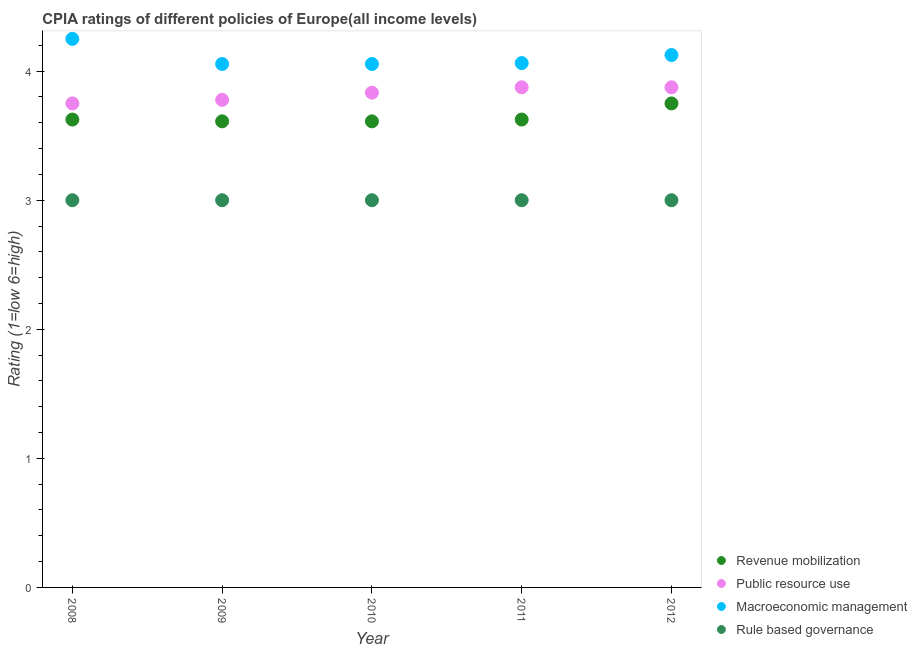How many different coloured dotlines are there?
Keep it short and to the point. 4. What is the cpia rating of public resource use in 2012?
Provide a short and direct response. 3.88. Across all years, what is the maximum cpia rating of rule based governance?
Offer a terse response. 3. What is the total cpia rating of rule based governance in the graph?
Provide a short and direct response. 15. What is the difference between the cpia rating of rule based governance in 2010 and that in 2012?
Make the answer very short. 0. What is the difference between the cpia rating of public resource use in 2011 and the cpia rating of rule based governance in 2009?
Your response must be concise. 0.88. What is the average cpia rating of revenue mobilization per year?
Give a very brief answer. 3.64. What is the ratio of the cpia rating of macroeconomic management in 2010 to that in 2012?
Your response must be concise. 0.98. Is the cpia rating of rule based governance in 2011 less than that in 2012?
Offer a very short reply. No. Is the difference between the cpia rating of revenue mobilization in 2009 and 2012 greater than the difference between the cpia rating of macroeconomic management in 2009 and 2012?
Keep it short and to the point. No. What is the difference between the highest and the lowest cpia rating of rule based governance?
Make the answer very short. 0. Is the sum of the cpia rating of rule based governance in 2009 and 2012 greater than the maximum cpia rating of revenue mobilization across all years?
Offer a very short reply. Yes. Is it the case that in every year, the sum of the cpia rating of macroeconomic management and cpia rating of public resource use is greater than the sum of cpia rating of revenue mobilization and cpia rating of rule based governance?
Ensure brevity in your answer.  No. Is it the case that in every year, the sum of the cpia rating of revenue mobilization and cpia rating of public resource use is greater than the cpia rating of macroeconomic management?
Make the answer very short. Yes. Is the cpia rating of public resource use strictly greater than the cpia rating of revenue mobilization over the years?
Your answer should be compact. Yes. Is the cpia rating of macroeconomic management strictly less than the cpia rating of public resource use over the years?
Provide a short and direct response. No. How many years are there in the graph?
Your answer should be compact. 5. Are the values on the major ticks of Y-axis written in scientific E-notation?
Offer a very short reply. No. Does the graph contain grids?
Your response must be concise. No. What is the title of the graph?
Give a very brief answer. CPIA ratings of different policies of Europe(all income levels). What is the label or title of the X-axis?
Your answer should be very brief. Year. What is the Rating (1=low 6=high) of Revenue mobilization in 2008?
Your answer should be very brief. 3.62. What is the Rating (1=low 6=high) of Public resource use in 2008?
Give a very brief answer. 3.75. What is the Rating (1=low 6=high) of Macroeconomic management in 2008?
Provide a short and direct response. 4.25. What is the Rating (1=low 6=high) in Rule based governance in 2008?
Keep it short and to the point. 3. What is the Rating (1=low 6=high) in Revenue mobilization in 2009?
Offer a terse response. 3.61. What is the Rating (1=low 6=high) in Public resource use in 2009?
Give a very brief answer. 3.78. What is the Rating (1=low 6=high) of Macroeconomic management in 2009?
Ensure brevity in your answer.  4.06. What is the Rating (1=low 6=high) of Revenue mobilization in 2010?
Provide a short and direct response. 3.61. What is the Rating (1=low 6=high) in Public resource use in 2010?
Your answer should be very brief. 3.83. What is the Rating (1=low 6=high) of Macroeconomic management in 2010?
Give a very brief answer. 4.06. What is the Rating (1=low 6=high) in Revenue mobilization in 2011?
Provide a succinct answer. 3.62. What is the Rating (1=low 6=high) of Public resource use in 2011?
Your answer should be very brief. 3.88. What is the Rating (1=low 6=high) of Macroeconomic management in 2011?
Provide a succinct answer. 4.06. What is the Rating (1=low 6=high) of Revenue mobilization in 2012?
Your answer should be compact. 3.75. What is the Rating (1=low 6=high) in Public resource use in 2012?
Keep it short and to the point. 3.88. What is the Rating (1=low 6=high) in Macroeconomic management in 2012?
Provide a succinct answer. 4.12. What is the Rating (1=low 6=high) of Rule based governance in 2012?
Provide a succinct answer. 3. Across all years, what is the maximum Rating (1=low 6=high) of Revenue mobilization?
Give a very brief answer. 3.75. Across all years, what is the maximum Rating (1=low 6=high) in Public resource use?
Your response must be concise. 3.88. Across all years, what is the maximum Rating (1=low 6=high) in Macroeconomic management?
Offer a very short reply. 4.25. Across all years, what is the maximum Rating (1=low 6=high) in Rule based governance?
Your answer should be very brief. 3. Across all years, what is the minimum Rating (1=low 6=high) of Revenue mobilization?
Provide a succinct answer. 3.61. Across all years, what is the minimum Rating (1=low 6=high) in Public resource use?
Your response must be concise. 3.75. Across all years, what is the minimum Rating (1=low 6=high) of Macroeconomic management?
Your answer should be compact. 4.06. Across all years, what is the minimum Rating (1=low 6=high) in Rule based governance?
Offer a terse response. 3. What is the total Rating (1=low 6=high) of Revenue mobilization in the graph?
Your response must be concise. 18.22. What is the total Rating (1=low 6=high) in Public resource use in the graph?
Your response must be concise. 19.11. What is the total Rating (1=low 6=high) of Macroeconomic management in the graph?
Provide a succinct answer. 20.55. What is the total Rating (1=low 6=high) in Rule based governance in the graph?
Make the answer very short. 15. What is the difference between the Rating (1=low 6=high) of Revenue mobilization in 2008 and that in 2009?
Ensure brevity in your answer.  0.01. What is the difference between the Rating (1=low 6=high) of Public resource use in 2008 and that in 2009?
Make the answer very short. -0.03. What is the difference between the Rating (1=low 6=high) of Macroeconomic management in 2008 and that in 2009?
Your answer should be very brief. 0.19. What is the difference between the Rating (1=low 6=high) in Revenue mobilization in 2008 and that in 2010?
Provide a succinct answer. 0.01. What is the difference between the Rating (1=low 6=high) of Public resource use in 2008 and that in 2010?
Keep it short and to the point. -0.08. What is the difference between the Rating (1=low 6=high) of Macroeconomic management in 2008 and that in 2010?
Make the answer very short. 0.19. What is the difference between the Rating (1=low 6=high) in Public resource use in 2008 and that in 2011?
Offer a terse response. -0.12. What is the difference between the Rating (1=low 6=high) in Macroeconomic management in 2008 and that in 2011?
Provide a succinct answer. 0.19. What is the difference between the Rating (1=low 6=high) of Rule based governance in 2008 and that in 2011?
Offer a terse response. 0. What is the difference between the Rating (1=low 6=high) in Revenue mobilization in 2008 and that in 2012?
Provide a short and direct response. -0.12. What is the difference between the Rating (1=low 6=high) in Public resource use in 2008 and that in 2012?
Offer a very short reply. -0.12. What is the difference between the Rating (1=low 6=high) in Macroeconomic management in 2008 and that in 2012?
Give a very brief answer. 0.12. What is the difference between the Rating (1=low 6=high) of Rule based governance in 2008 and that in 2012?
Provide a succinct answer. 0. What is the difference between the Rating (1=low 6=high) in Revenue mobilization in 2009 and that in 2010?
Ensure brevity in your answer.  0. What is the difference between the Rating (1=low 6=high) of Public resource use in 2009 and that in 2010?
Keep it short and to the point. -0.06. What is the difference between the Rating (1=low 6=high) of Macroeconomic management in 2009 and that in 2010?
Provide a succinct answer. 0. What is the difference between the Rating (1=low 6=high) of Rule based governance in 2009 and that in 2010?
Provide a succinct answer. 0. What is the difference between the Rating (1=low 6=high) in Revenue mobilization in 2009 and that in 2011?
Your answer should be very brief. -0.01. What is the difference between the Rating (1=low 6=high) in Public resource use in 2009 and that in 2011?
Make the answer very short. -0.1. What is the difference between the Rating (1=low 6=high) in Macroeconomic management in 2009 and that in 2011?
Offer a very short reply. -0.01. What is the difference between the Rating (1=low 6=high) in Rule based governance in 2009 and that in 2011?
Ensure brevity in your answer.  0. What is the difference between the Rating (1=low 6=high) in Revenue mobilization in 2009 and that in 2012?
Keep it short and to the point. -0.14. What is the difference between the Rating (1=low 6=high) in Public resource use in 2009 and that in 2012?
Ensure brevity in your answer.  -0.1. What is the difference between the Rating (1=low 6=high) of Macroeconomic management in 2009 and that in 2012?
Ensure brevity in your answer.  -0.07. What is the difference between the Rating (1=low 6=high) in Revenue mobilization in 2010 and that in 2011?
Keep it short and to the point. -0.01. What is the difference between the Rating (1=low 6=high) in Public resource use in 2010 and that in 2011?
Ensure brevity in your answer.  -0.04. What is the difference between the Rating (1=low 6=high) of Macroeconomic management in 2010 and that in 2011?
Ensure brevity in your answer.  -0.01. What is the difference between the Rating (1=low 6=high) of Rule based governance in 2010 and that in 2011?
Offer a very short reply. 0. What is the difference between the Rating (1=low 6=high) in Revenue mobilization in 2010 and that in 2012?
Provide a succinct answer. -0.14. What is the difference between the Rating (1=low 6=high) in Public resource use in 2010 and that in 2012?
Make the answer very short. -0.04. What is the difference between the Rating (1=low 6=high) in Macroeconomic management in 2010 and that in 2012?
Keep it short and to the point. -0.07. What is the difference between the Rating (1=low 6=high) of Revenue mobilization in 2011 and that in 2012?
Keep it short and to the point. -0.12. What is the difference between the Rating (1=low 6=high) of Public resource use in 2011 and that in 2012?
Provide a short and direct response. 0. What is the difference between the Rating (1=low 6=high) of Macroeconomic management in 2011 and that in 2012?
Give a very brief answer. -0.06. What is the difference between the Rating (1=low 6=high) of Revenue mobilization in 2008 and the Rating (1=low 6=high) of Public resource use in 2009?
Your answer should be compact. -0.15. What is the difference between the Rating (1=low 6=high) of Revenue mobilization in 2008 and the Rating (1=low 6=high) of Macroeconomic management in 2009?
Your answer should be compact. -0.43. What is the difference between the Rating (1=low 6=high) in Revenue mobilization in 2008 and the Rating (1=low 6=high) in Rule based governance in 2009?
Your response must be concise. 0.62. What is the difference between the Rating (1=low 6=high) of Public resource use in 2008 and the Rating (1=low 6=high) of Macroeconomic management in 2009?
Keep it short and to the point. -0.31. What is the difference between the Rating (1=low 6=high) in Public resource use in 2008 and the Rating (1=low 6=high) in Rule based governance in 2009?
Offer a terse response. 0.75. What is the difference between the Rating (1=low 6=high) of Revenue mobilization in 2008 and the Rating (1=low 6=high) of Public resource use in 2010?
Make the answer very short. -0.21. What is the difference between the Rating (1=low 6=high) in Revenue mobilization in 2008 and the Rating (1=low 6=high) in Macroeconomic management in 2010?
Make the answer very short. -0.43. What is the difference between the Rating (1=low 6=high) in Public resource use in 2008 and the Rating (1=low 6=high) in Macroeconomic management in 2010?
Make the answer very short. -0.31. What is the difference between the Rating (1=low 6=high) of Public resource use in 2008 and the Rating (1=low 6=high) of Rule based governance in 2010?
Ensure brevity in your answer.  0.75. What is the difference between the Rating (1=low 6=high) in Revenue mobilization in 2008 and the Rating (1=low 6=high) in Macroeconomic management in 2011?
Offer a very short reply. -0.44. What is the difference between the Rating (1=low 6=high) in Public resource use in 2008 and the Rating (1=low 6=high) in Macroeconomic management in 2011?
Provide a succinct answer. -0.31. What is the difference between the Rating (1=low 6=high) in Macroeconomic management in 2008 and the Rating (1=low 6=high) in Rule based governance in 2011?
Provide a short and direct response. 1.25. What is the difference between the Rating (1=low 6=high) of Revenue mobilization in 2008 and the Rating (1=low 6=high) of Public resource use in 2012?
Your answer should be very brief. -0.25. What is the difference between the Rating (1=low 6=high) of Revenue mobilization in 2008 and the Rating (1=low 6=high) of Rule based governance in 2012?
Offer a terse response. 0.62. What is the difference between the Rating (1=low 6=high) in Public resource use in 2008 and the Rating (1=low 6=high) in Macroeconomic management in 2012?
Ensure brevity in your answer.  -0.38. What is the difference between the Rating (1=low 6=high) in Macroeconomic management in 2008 and the Rating (1=low 6=high) in Rule based governance in 2012?
Provide a succinct answer. 1.25. What is the difference between the Rating (1=low 6=high) in Revenue mobilization in 2009 and the Rating (1=low 6=high) in Public resource use in 2010?
Provide a succinct answer. -0.22. What is the difference between the Rating (1=low 6=high) in Revenue mobilization in 2009 and the Rating (1=low 6=high) in Macroeconomic management in 2010?
Your answer should be compact. -0.44. What is the difference between the Rating (1=low 6=high) of Revenue mobilization in 2009 and the Rating (1=low 6=high) of Rule based governance in 2010?
Make the answer very short. 0.61. What is the difference between the Rating (1=low 6=high) of Public resource use in 2009 and the Rating (1=low 6=high) of Macroeconomic management in 2010?
Offer a terse response. -0.28. What is the difference between the Rating (1=low 6=high) in Public resource use in 2009 and the Rating (1=low 6=high) in Rule based governance in 2010?
Give a very brief answer. 0.78. What is the difference between the Rating (1=low 6=high) in Macroeconomic management in 2009 and the Rating (1=low 6=high) in Rule based governance in 2010?
Offer a terse response. 1.06. What is the difference between the Rating (1=low 6=high) in Revenue mobilization in 2009 and the Rating (1=low 6=high) in Public resource use in 2011?
Provide a short and direct response. -0.26. What is the difference between the Rating (1=low 6=high) of Revenue mobilization in 2009 and the Rating (1=low 6=high) of Macroeconomic management in 2011?
Your answer should be very brief. -0.45. What is the difference between the Rating (1=low 6=high) in Revenue mobilization in 2009 and the Rating (1=low 6=high) in Rule based governance in 2011?
Ensure brevity in your answer.  0.61. What is the difference between the Rating (1=low 6=high) of Public resource use in 2009 and the Rating (1=low 6=high) of Macroeconomic management in 2011?
Give a very brief answer. -0.28. What is the difference between the Rating (1=low 6=high) in Public resource use in 2009 and the Rating (1=low 6=high) in Rule based governance in 2011?
Provide a succinct answer. 0.78. What is the difference between the Rating (1=low 6=high) in Macroeconomic management in 2009 and the Rating (1=low 6=high) in Rule based governance in 2011?
Your response must be concise. 1.06. What is the difference between the Rating (1=low 6=high) of Revenue mobilization in 2009 and the Rating (1=low 6=high) of Public resource use in 2012?
Make the answer very short. -0.26. What is the difference between the Rating (1=low 6=high) of Revenue mobilization in 2009 and the Rating (1=low 6=high) of Macroeconomic management in 2012?
Provide a succinct answer. -0.51. What is the difference between the Rating (1=low 6=high) of Revenue mobilization in 2009 and the Rating (1=low 6=high) of Rule based governance in 2012?
Provide a succinct answer. 0.61. What is the difference between the Rating (1=low 6=high) in Public resource use in 2009 and the Rating (1=low 6=high) in Macroeconomic management in 2012?
Keep it short and to the point. -0.35. What is the difference between the Rating (1=low 6=high) of Macroeconomic management in 2009 and the Rating (1=low 6=high) of Rule based governance in 2012?
Provide a short and direct response. 1.06. What is the difference between the Rating (1=low 6=high) in Revenue mobilization in 2010 and the Rating (1=low 6=high) in Public resource use in 2011?
Make the answer very short. -0.26. What is the difference between the Rating (1=low 6=high) of Revenue mobilization in 2010 and the Rating (1=low 6=high) of Macroeconomic management in 2011?
Provide a succinct answer. -0.45. What is the difference between the Rating (1=low 6=high) in Revenue mobilization in 2010 and the Rating (1=low 6=high) in Rule based governance in 2011?
Keep it short and to the point. 0.61. What is the difference between the Rating (1=low 6=high) in Public resource use in 2010 and the Rating (1=low 6=high) in Macroeconomic management in 2011?
Provide a short and direct response. -0.23. What is the difference between the Rating (1=low 6=high) in Macroeconomic management in 2010 and the Rating (1=low 6=high) in Rule based governance in 2011?
Your answer should be compact. 1.06. What is the difference between the Rating (1=low 6=high) in Revenue mobilization in 2010 and the Rating (1=low 6=high) in Public resource use in 2012?
Keep it short and to the point. -0.26. What is the difference between the Rating (1=low 6=high) of Revenue mobilization in 2010 and the Rating (1=low 6=high) of Macroeconomic management in 2012?
Ensure brevity in your answer.  -0.51. What is the difference between the Rating (1=low 6=high) of Revenue mobilization in 2010 and the Rating (1=low 6=high) of Rule based governance in 2012?
Ensure brevity in your answer.  0.61. What is the difference between the Rating (1=low 6=high) in Public resource use in 2010 and the Rating (1=low 6=high) in Macroeconomic management in 2012?
Keep it short and to the point. -0.29. What is the difference between the Rating (1=low 6=high) of Macroeconomic management in 2010 and the Rating (1=low 6=high) of Rule based governance in 2012?
Your response must be concise. 1.06. What is the difference between the Rating (1=low 6=high) in Revenue mobilization in 2011 and the Rating (1=low 6=high) in Macroeconomic management in 2012?
Make the answer very short. -0.5. What is the difference between the Rating (1=low 6=high) of Public resource use in 2011 and the Rating (1=low 6=high) of Rule based governance in 2012?
Offer a very short reply. 0.88. What is the average Rating (1=low 6=high) in Revenue mobilization per year?
Your response must be concise. 3.64. What is the average Rating (1=low 6=high) in Public resource use per year?
Offer a terse response. 3.82. What is the average Rating (1=low 6=high) in Macroeconomic management per year?
Offer a very short reply. 4.11. What is the average Rating (1=low 6=high) in Rule based governance per year?
Ensure brevity in your answer.  3. In the year 2008, what is the difference between the Rating (1=low 6=high) in Revenue mobilization and Rating (1=low 6=high) in Public resource use?
Make the answer very short. -0.12. In the year 2008, what is the difference between the Rating (1=low 6=high) of Revenue mobilization and Rating (1=low 6=high) of Macroeconomic management?
Your answer should be very brief. -0.62. In the year 2008, what is the difference between the Rating (1=low 6=high) in Public resource use and Rating (1=low 6=high) in Rule based governance?
Your response must be concise. 0.75. In the year 2008, what is the difference between the Rating (1=low 6=high) in Macroeconomic management and Rating (1=low 6=high) in Rule based governance?
Your response must be concise. 1.25. In the year 2009, what is the difference between the Rating (1=low 6=high) in Revenue mobilization and Rating (1=low 6=high) in Public resource use?
Offer a very short reply. -0.17. In the year 2009, what is the difference between the Rating (1=low 6=high) of Revenue mobilization and Rating (1=low 6=high) of Macroeconomic management?
Offer a very short reply. -0.44. In the year 2009, what is the difference between the Rating (1=low 6=high) of Revenue mobilization and Rating (1=low 6=high) of Rule based governance?
Ensure brevity in your answer.  0.61. In the year 2009, what is the difference between the Rating (1=low 6=high) of Public resource use and Rating (1=low 6=high) of Macroeconomic management?
Keep it short and to the point. -0.28. In the year 2009, what is the difference between the Rating (1=low 6=high) of Macroeconomic management and Rating (1=low 6=high) of Rule based governance?
Offer a terse response. 1.06. In the year 2010, what is the difference between the Rating (1=low 6=high) in Revenue mobilization and Rating (1=low 6=high) in Public resource use?
Provide a short and direct response. -0.22. In the year 2010, what is the difference between the Rating (1=low 6=high) of Revenue mobilization and Rating (1=low 6=high) of Macroeconomic management?
Provide a short and direct response. -0.44. In the year 2010, what is the difference between the Rating (1=low 6=high) in Revenue mobilization and Rating (1=low 6=high) in Rule based governance?
Give a very brief answer. 0.61. In the year 2010, what is the difference between the Rating (1=low 6=high) of Public resource use and Rating (1=low 6=high) of Macroeconomic management?
Offer a terse response. -0.22. In the year 2010, what is the difference between the Rating (1=low 6=high) in Public resource use and Rating (1=low 6=high) in Rule based governance?
Your answer should be very brief. 0.83. In the year 2010, what is the difference between the Rating (1=low 6=high) of Macroeconomic management and Rating (1=low 6=high) of Rule based governance?
Your response must be concise. 1.06. In the year 2011, what is the difference between the Rating (1=low 6=high) in Revenue mobilization and Rating (1=low 6=high) in Macroeconomic management?
Provide a succinct answer. -0.44. In the year 2011, what is the difference between the Rating (1=low 6=high) of Revenue mobilization and Rating (1=low 6=high) of Rule based governance?
Your answer should be very brief. 0.62. In the year 2011, what is the difference between the Rating (1=low 6=high) of Public resource use and Rating (1=low 6=high) of Macroeconomic management?
Your response must be concise. -0.19. In the year 2011, what is the difference between the Rating (1=low 6=high) of Macroeconomic management and Rating (1=low 6=high) of Rule based governance?
Provide a short and direct response. 1.06. In the year 2012, what is the difference between the Rating (1=low 6=high) in Revenue mobilization and Rating (1=low 6=high) in Public resource use?
Offer a terse response. -0.12. In the year 2012, what is the difference between the Rating (1=low 6=high) in Revenue mobilization and Rating (1=low 6=high) in Macroeconomic management?
Provide a short and direct response. -0.38. In the year 2012, what is the difference between the Rating (1=low 6=high) of Macroeconomic management and Rating (1=low 6=high) of Rule based governance?
Your response must be concise. 1.12. What is the ratio of the Rating (1=low 6=high) of Public resource use in 2008 to that in 2009?
Provide a short and direct response. 0.99. What is the ratio of the Rating (1=low 6=high) of Macroeconomic management in 2008 to that in 2009?
Your answer should be very brief. 1.05. What is the ratio of the Rating (1=low 6=high) in Rule based governance in 2008 to that in 2009?
Give a very brief answer. 1. What is the ratio of the Rating (1=low 6=high) of Public resource use in 2008 to that in 2010?
Offer a terse response. 0.98. What is the ratio of the Rating (1=low 6=high) in Macroeconomic management in 2008 to that in 2010?
Make the answer very short. 1.05. What is the ratio of the Rating (1=low 6=high) of Rule based governance in 2008 to that in 2010?
Make the answer very short. 1. What is the ratio of the Rating (1=low 6=high) of Macroeconomic management in 2008 to that in 2011?
Provide a succinct answer. 1.05. What is the ratio of the Rating (1=low 6=high) of Revenue mobilization in 2008 to that in 2012?
Keep it short and to the point. 0.97. What is the ratio of the Rating (1=low 6=high) in Macroeconomic management in 2008 to that in 2012?
Ensure brevity in your answer.  1.03. What is the ratio of the Rating (1=low 6=high) of Public resource use in 2009 to that in 2010?
Your answer should be very brief. 0.99. What is the ratio of the Rating (1=low 6=high) in Public resource use in 2009 to that in 2011?
Make the answer very short. 0.97. What is the ratio of the Rating (1=low 6=high) in Public resource use in 2009 to that in 2012?
Provide a succinct answer. 0.97. What is the ratio of the Rating (1=low 6=high) of Macroeconomic management in 2009 to that in 2012?
Your answer should be compact. 0.98. What is the ratio of the Rating (1=low 6=high) in Rule based governance in 2009 to that in 2012?
Provide a short and direct response. 1. What is the ratio of the Rating (1=low 6=high) in Revenue mobilization in 2010 to that in 2011?
Keep it short and to the point. 1. What is the ratio of the Rating (1=low 6=high) of Public resource use in 2010 to that in 2011?
Your answer should be compact. 0.99. What is the ratio of the Rating (1=low 6=high) of Macroeconomic management in 2010 to that in 2011?
Provide a succinct answer. 1. What is the ratio of the Rating (1=low 6=high) in Rule based governance in 2010 to that in 2011?
Make the answer very short. 1. What is the ratio of the Rating (1=low 6=high) of Public resource use in 2010 to that in 2012?
Provide a short and direct response. 0.99. What is the ratio of the Rating (1=low 6=high) of Macroeconomic management in 2010 to that in 2012?
Offer a terse response. 0.98. What is the ratio of the Rating (1=low 6=high) of Rule based governance in 2010 to that in 2012?
Offer a terse response. 1. What is the ratio of the Rating (1=low 6=high) in Revenue mobilization in 2011 to that in 2012?
Give a very brief answer. 0.97. What is the difference between the highest and the second highest Rating (1=low 6=high) of Revenue mobilization?
Provide a succinct answer. 0.12. What is the difference between the highest and the second highest Rating (1=low 6=high) in Macroeconomic management?
Offer a terse response. 0.12. What is the difference between the highest and the second highest Rating (1=low 6=high) in Rule based governance?
Offer a terse response. 0. What is the difference between the highest and the lowest Rating (1=low 6=high) of Revenue mobilization?
Ensure brevity in your answer.  0.14. What is the difference between the highest and the lowest Rating (1=low 6=high) in Macroeconomic management?
Provide a short and direct response. 0.19. What is the difference between the highest and the lowest Rating (1=low 6=high) in Rule based governance?
Provide a short and direct response. 0. 